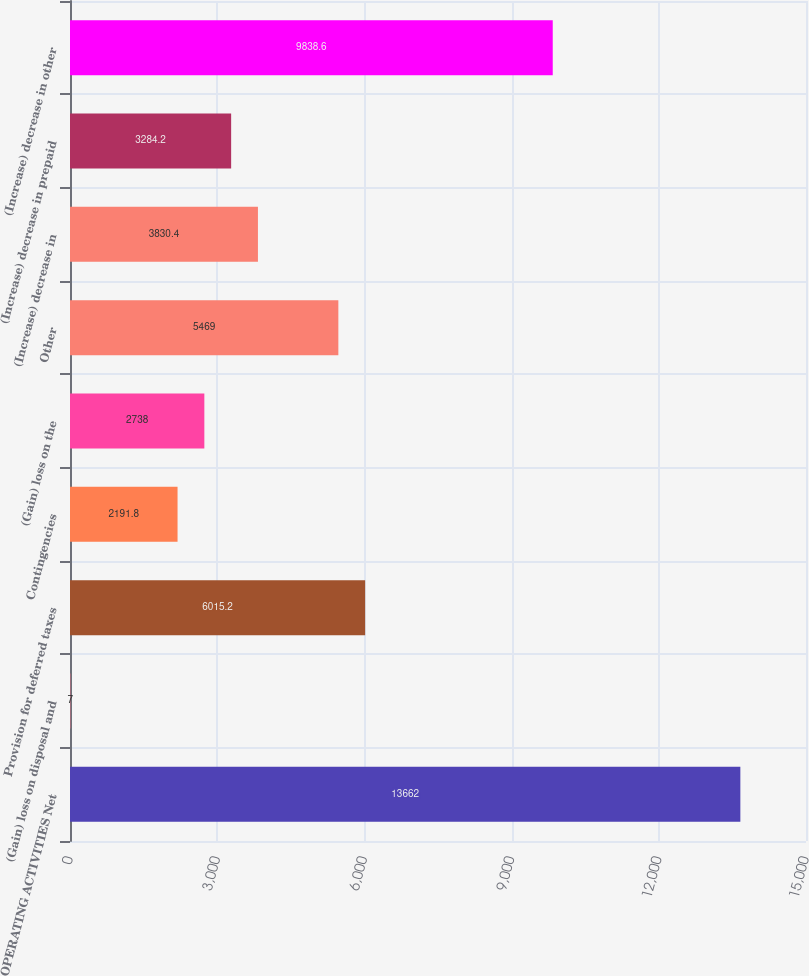<chart> <loc_0><loc_0><loc_500><loc_500><bar_chart><fcel>OPERATING ACTIVITIES Net<fcel>(Gain) loss on disposal and<fcel>Provision for deferred taxes<fcel>Contingencies<fcel>(Gain) loss on the<fcel>Other<fcel>(Increase) decrease in<fcel>(Increase) decrease in prepaid<fcel>(Increase) decrease in other<nl><fcel>13662<fcel>7<fcel>6015.2<fcel>2191.8<fcel>2738<fcel>5469<fcel>3830.4<fcel>3284.2<fcel>9838.6<nl></chart> 